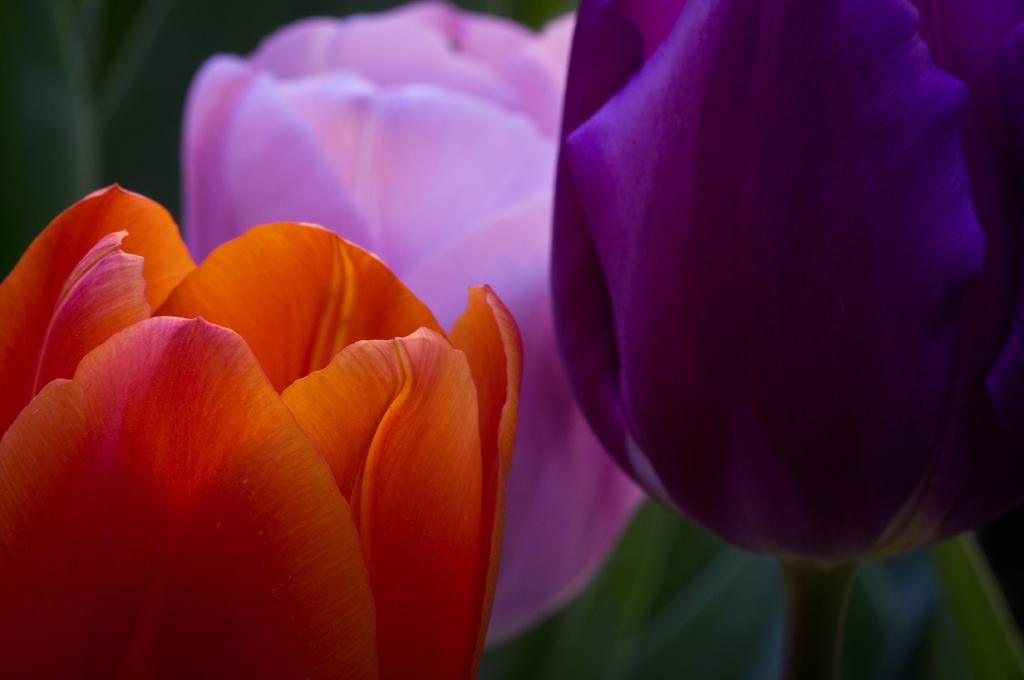What type of plants can be seen in the image? There are flowers in the image. Can you describe the appearance of the flowers? The flowers have different colors. What type of noise do the fairies make while dancing around the flowers in the image? There are no fairies present in the image, so it is not possible to determine the noise they might make. 